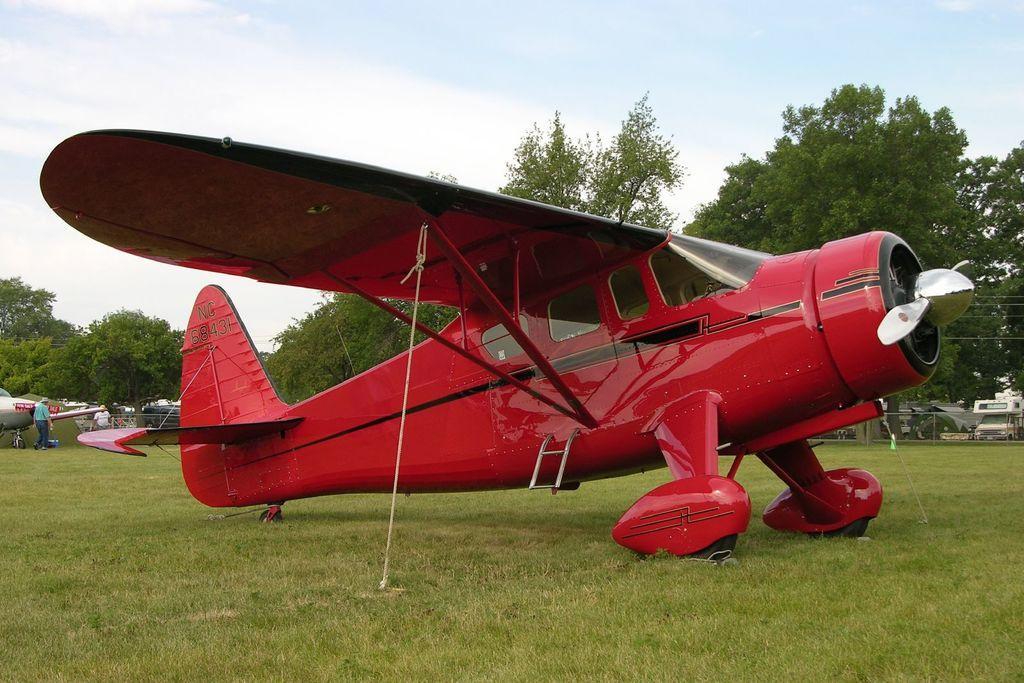Please provide a concise description of this image. This is an outside view. In the middle of the image there is a red color airplane on the ground. On the left side there is another airplane and two persons are standing. At the bottom, I can see the grass on the ground. In the background there are few vehicles and trees. On the right side there is a net fencing. At the top of the image I can see the sky. 